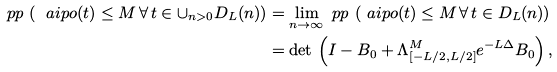Convert formula to latex. <formula><loc_0><loc_0><loc_500><loc_500>\ p p \, \left ( \ a i p o ( t ) \leq M \, \forall \, t \in \cup _ { n > 0 } D _ { L } ( n ) \right ) & = \lim _ { n \to \infty } \ p p \, \left ( \ a i p o ( t ) \leq M \, \forall \, t \in D _ { L } ( n ) \right ) \\ & = \det \, \left ( I - B _ { 0 } + \Lambda ^ { M } _ { [ - L / 2 , L / 2 ] } e ^ { - L \Delta } B _ { 0 } \right ) ,</formula> 